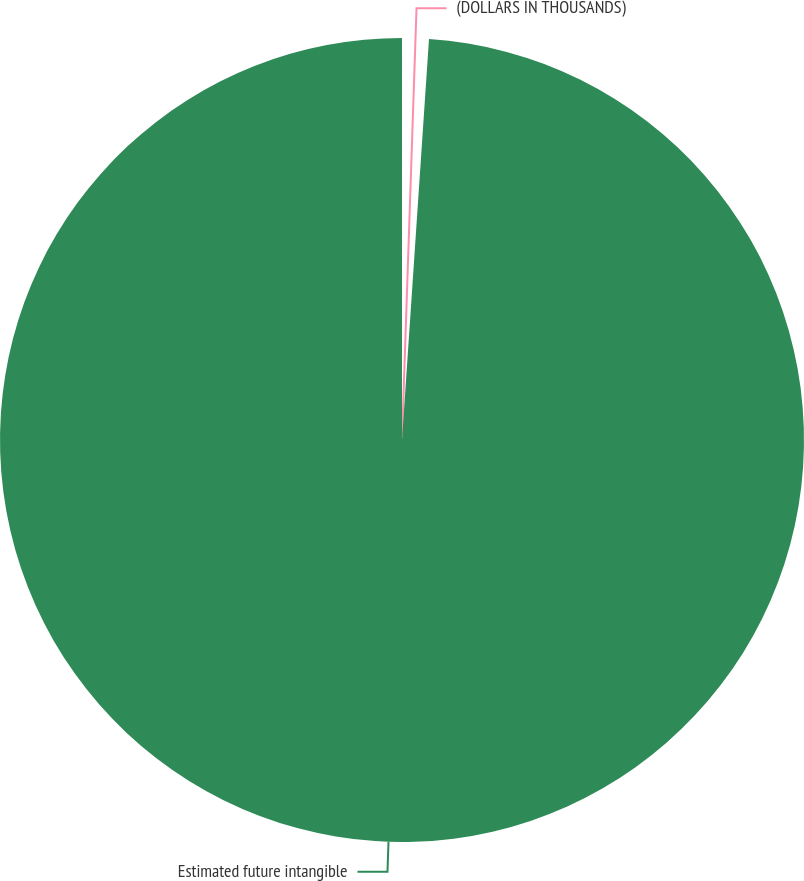Convert chart. <chart><loc_0><loc_0><loc_500><loc_500><pie_chart><fcel>(DOLLARS IN THOUSANDS)<fcel>Estimated future intangible<nl><fcel>1.07%<fcel>98.93%<nl></chart> 